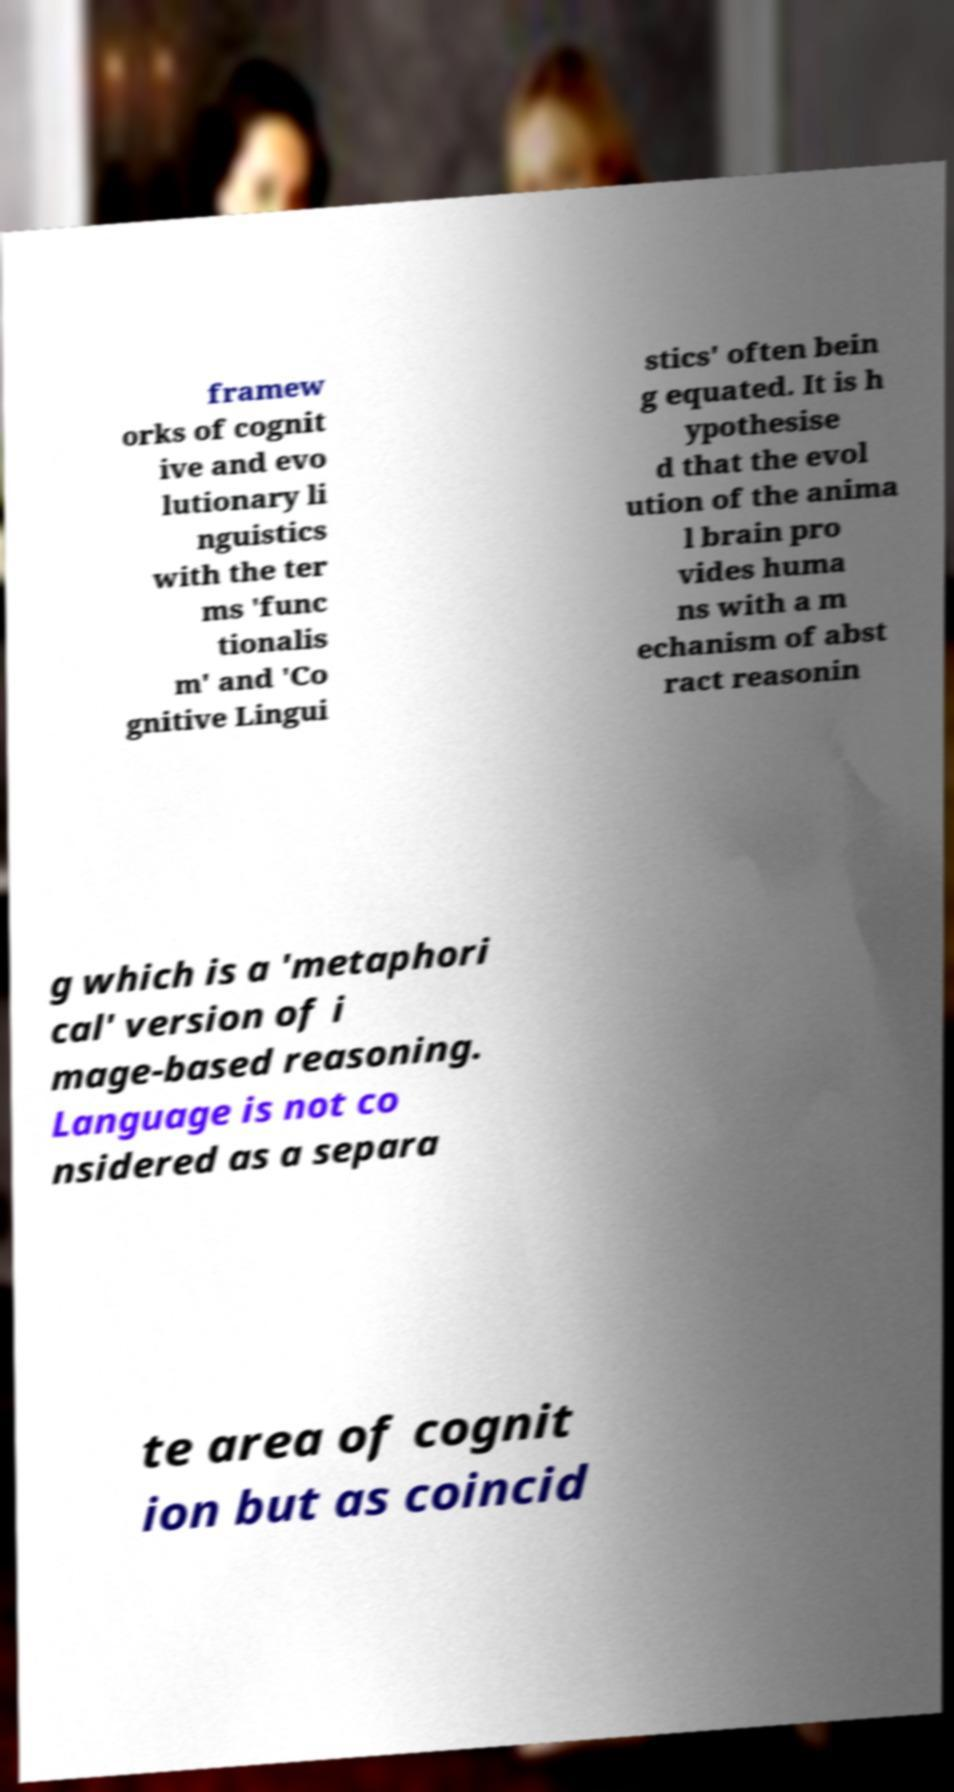Can you read and provide the text displayed in the image?This photo seems to have some interesting text. Can you extract and type it out for me? framew orks of cognit ive and evo lutionary li nguistics with the ter ms 'func tionalis m' and 'Co gnitive Lingui stics' often bein g equated. It is h ypothesise d that the evol ution of the anima l brain pro vides huma ns with a m echanism of abst ract reasonin g which is a 'metaphori cal' version of i mage-based reasoning. Language is not co nsidered as a separa te area of cognit ion but as coincid 